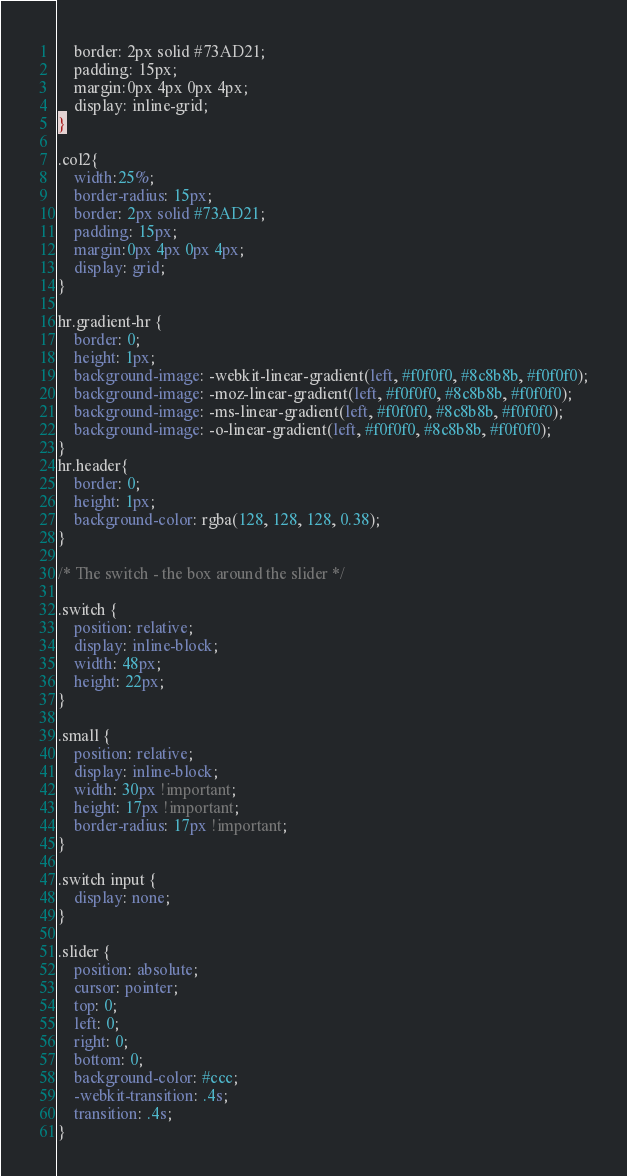Convert code to text. <code><loc_0><loc_0><loc_500><loc_500><_CSS_>    border: 2px solid #73AD21;
    padding: 15px;
    margin:0px 4px 0px 4px;
    display: inline-grid;
}

.col2{
    width:25%;
    border-radius: 15px;
    border: 2px solid #73AD21;
    padding: 15px;
    margin:0px 4px 0px 4px;
    display: grid;
}

hr.gradient-hr {
    border: 0;
    height: 1px;
    background-image: -webkit-linear-gradient(left, #f0f0f0, #8c8b8b, #f0f0f0);
    background-image: -moz-linear-gradient(left, #f0f0f0, #8c8b8b, #f0f0f0);
    background-image: -ms-linear-gradient(left, #f0f0f0, #8c8b8b, #f0f0f0);
    background-image: -o-linear-gradient(left, #f0f0f0, #8c8b8b, #f0f0f0);
}
hr.header{
    border: 0;
    height: 1px;
    background-color: rgba(128, 128, 128, 0.38);
}

/* The switch - the box around the slider */

.switch {
    position: relative;
    display: inline-block;
    width: 48px;
    height: 22px;
}

.small {
    position: relative;
    display: inline-block;
    width: 30px !important;
    height: 17px !important;
    border-radius: 17px !important;
}

.switch input {
    display: none;
}

.slider {
    position: absolute;
    cursor: pointer;
    top: 0;
    left: 0;
    right: 0;
    bottom: 0;
    background-color: #ccc;
    -webkit-transition: .4s;
    transition: .4s;
}
</code> 